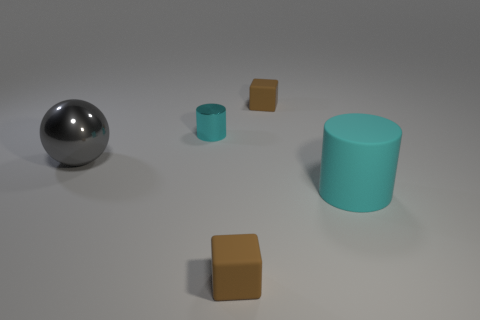Subtract 2 cylinders. How many cylinders are left? 0 Add 2 small shiny things. How many objects exist? 7 Subtract all blocks. How many objects are left? 3 Subtract all tiny green metal objects. Subtract all big cyan rubber things. How many objects are left? 4 Add 3 cyan shiny things. How many cyan shiny things are left? 4 Add 3 big rubber cylinders. How many big rubber cylinders exist? 4 Subtract 0 red cubes. How many objects are left? 5 